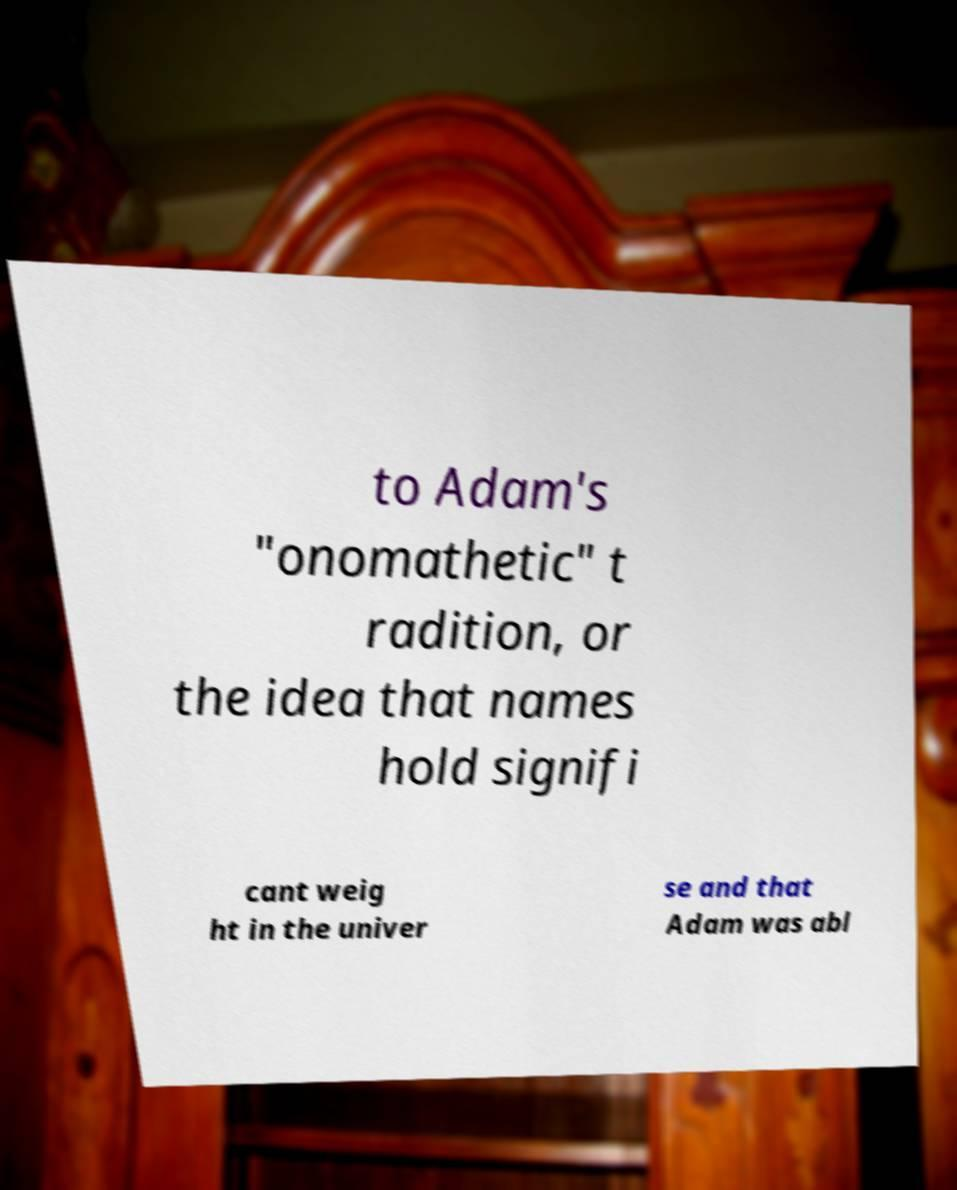What messages or text are displayed in this image? I need them in a readable, typed format. to Adam's "onomathetic" t radition, or the idea that names hold signifi cant weig ht in the univer se and that Adam was abl 